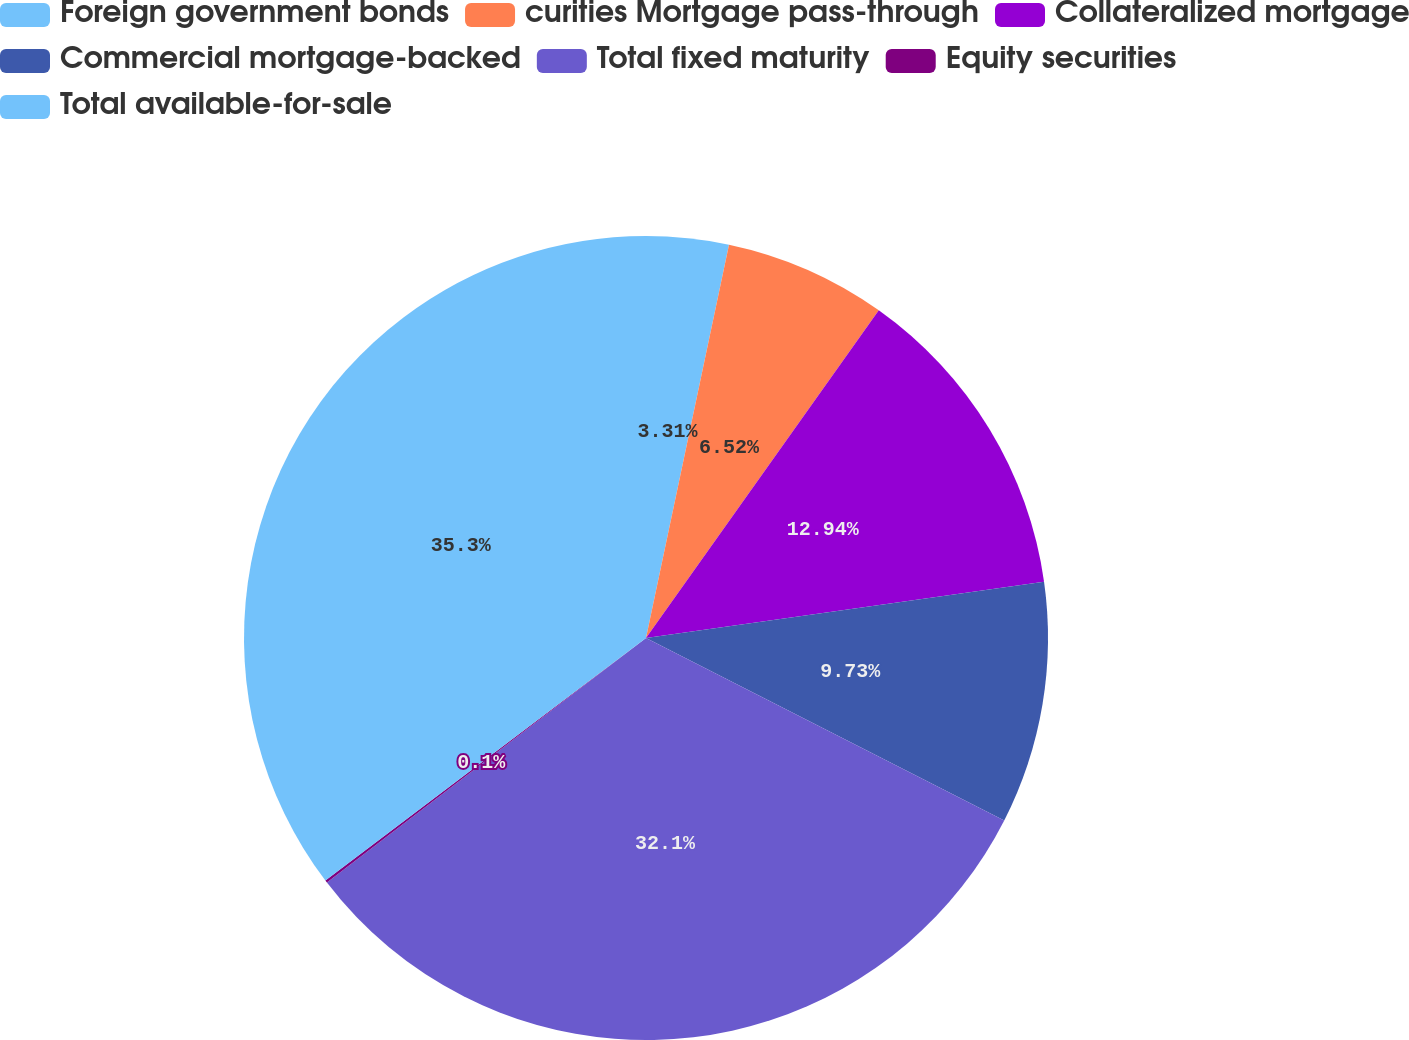Convert chart to OTSL. <chart><loc_0><loc_0><loc_500><loc_500><pie_chart><fcel>Foreign government bonds<fcel>curities Mortgage pass-through<fcel>Collateralized mortgage<fcel>Commercial mortgage-backed<fcel>Total fixed maturity<fcel>Equity securities<fcel>Total available-for-sale<nl><fcel>3.31%<fcel>6.52%<fcel>12.94%<fcel>9.73%<fcel>32.1%<fcel>0.1%<fcel>35.31%<nl></chart> 